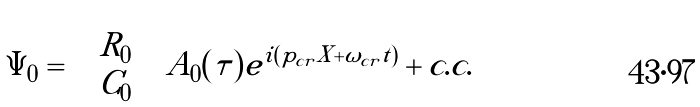Convert formula to latex. <formula><loc_0><loc_0><loc_500><loc_500>\Psi _ { 0 } = \left ( \begin{array} { c c } R _ { 0 } \\ C _ { 0 } \end{array} \right ) A _ { 0 } ( \tau ) e ^ { i ( p _ { c r } X + \omega _ { c r } t ) } + c . c .</formula> 